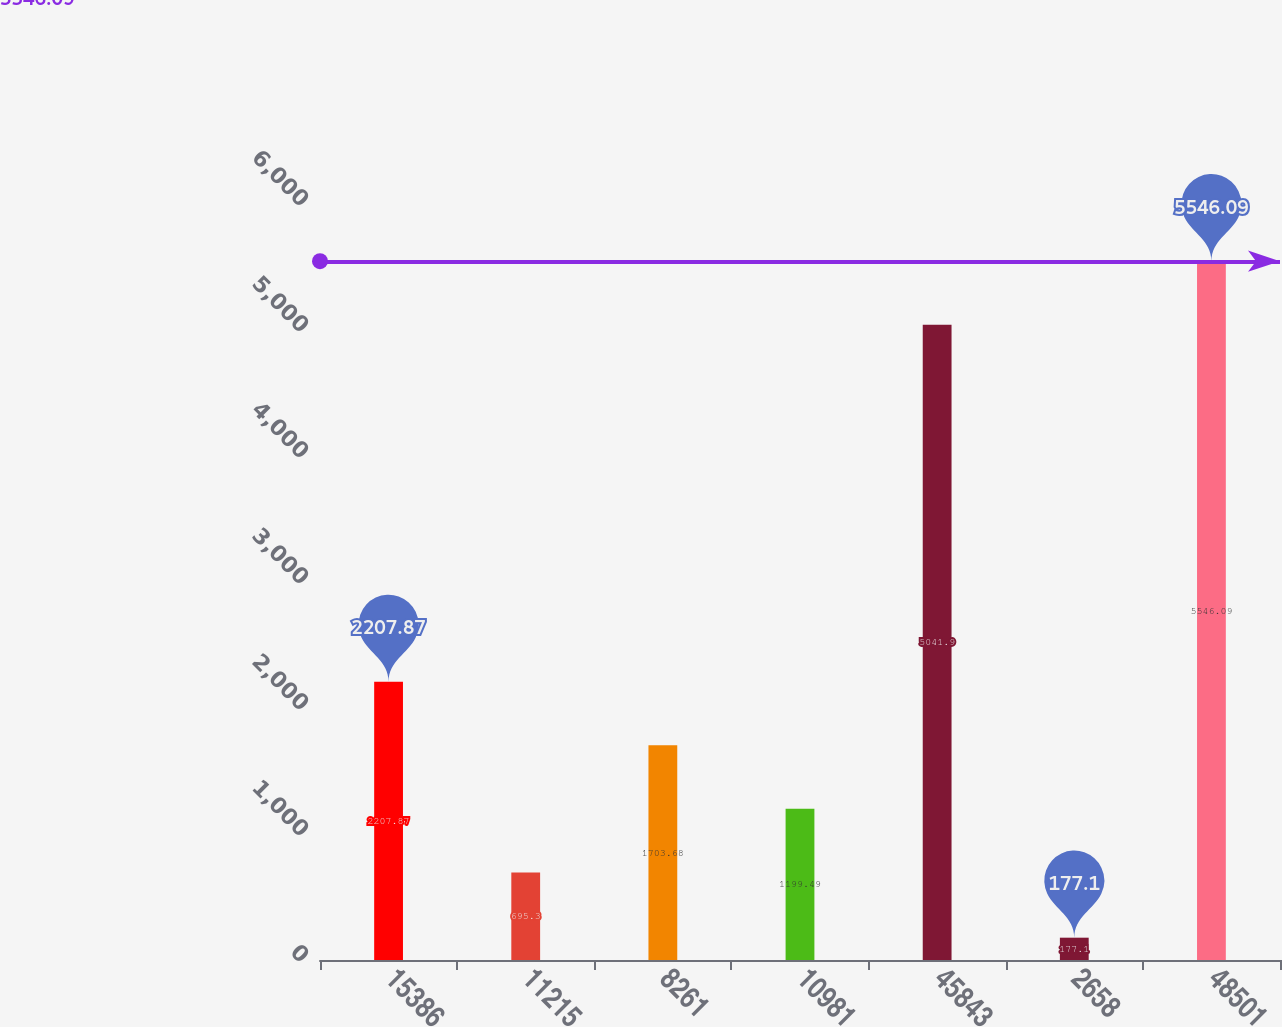Convert chart. <chart><loc_0><loc_0><loc_500><loc_500><bar_chart><fcel>15386<fcel>11215<fcel>8261<fcel>10981<fcel>45843<fcel>2658<fcel>48501<nl><fcel>2207.87<fcel>695.3<fcel>1703.68<fcel>1199.49<fcel>5041.9<fcel>177.1<fcel>5546.09<nl></chart> 